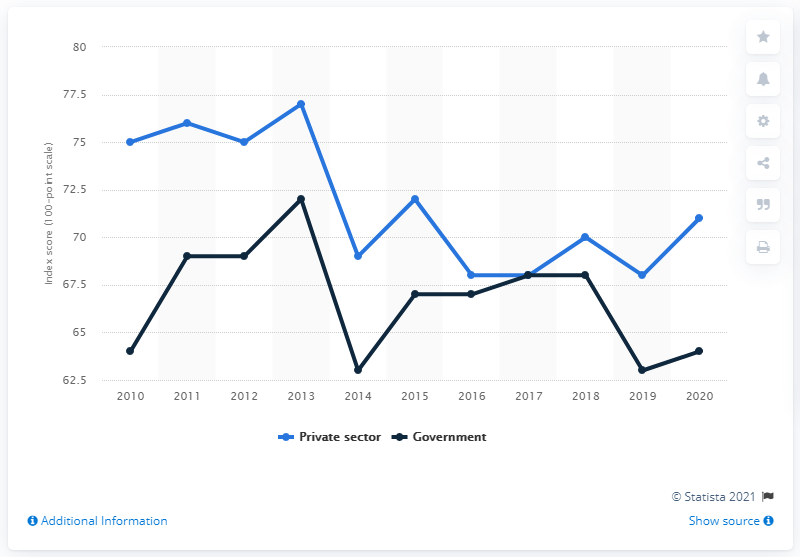Specify some key components in this picture. According to a survey conducted in 2020, the satisfaction index score for the global contact center industry in the private sector was 71. 